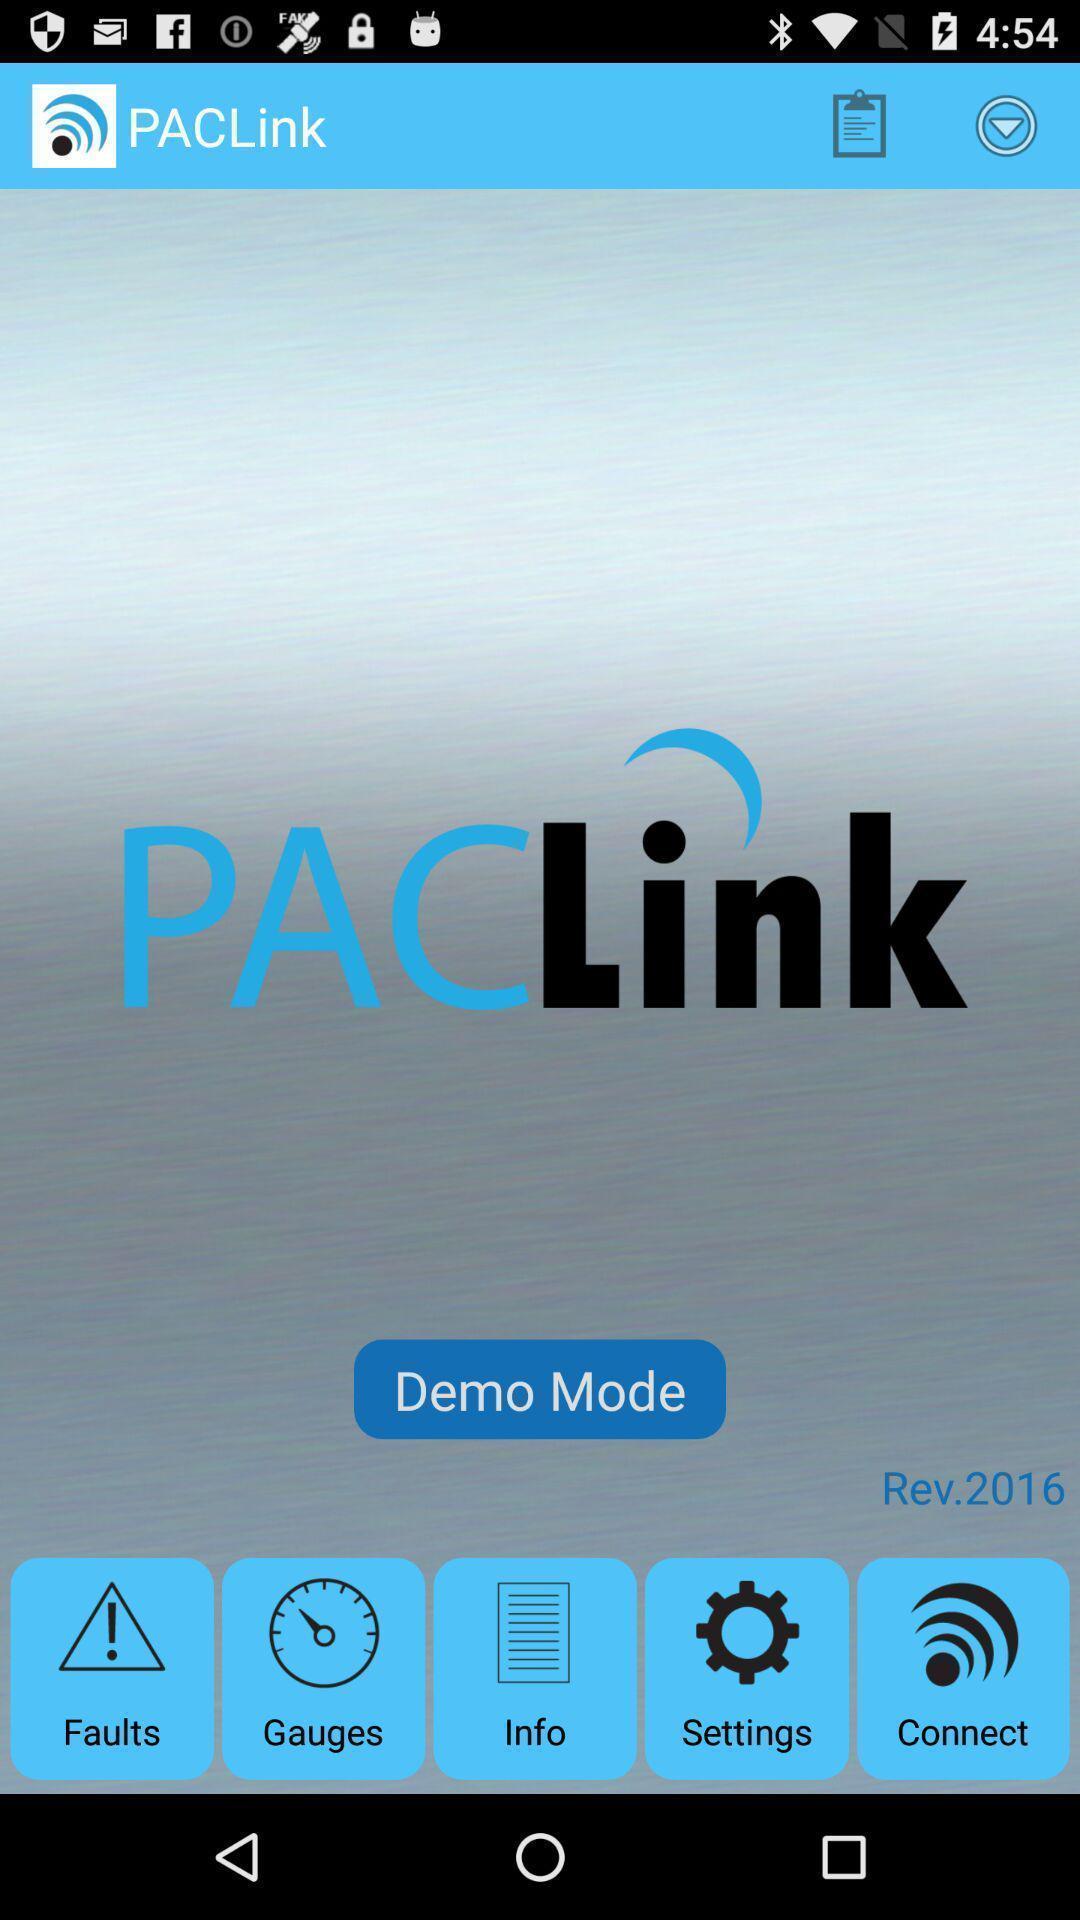What can you discern from this picture? Page displaying list different options in app. 